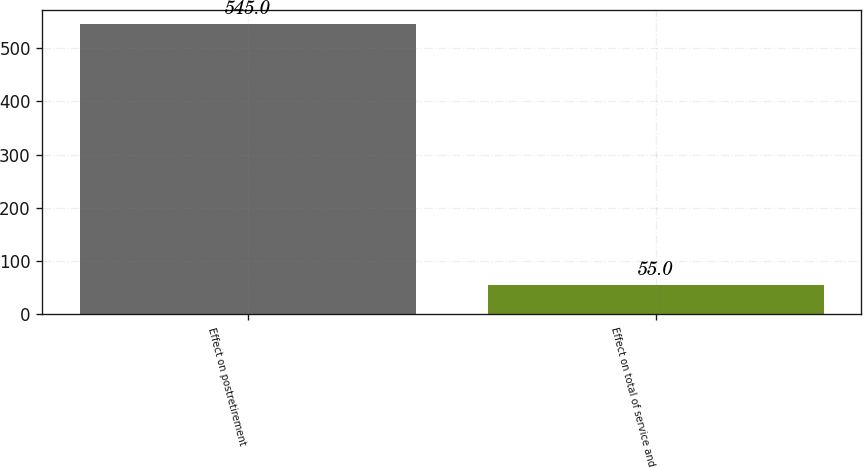Convert chart. <chart><loc_0><loc_0><loc_500><loc_500><bar_chart><fcel>Effect on postretirement<fcel>Effect on total of service and<nl><fcel>545<fcel>55<nl></chart> 